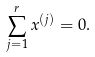Convert formula to latex. <formula><loc_0><loc_0><loc_500><loc_500>\sum _ { j = 1 } ^ { r } x ^ { ( j ) } = 0 .</formula> 